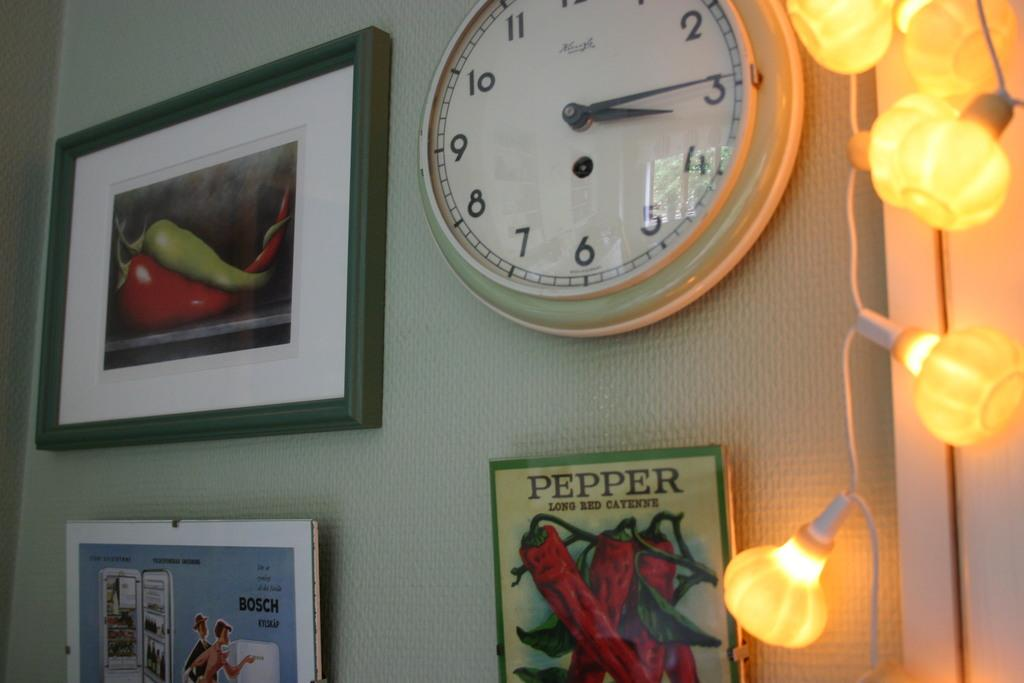<image>
Offer a succinct explanation of the picture presented. Clock above a poster which says PEPPER on it. 